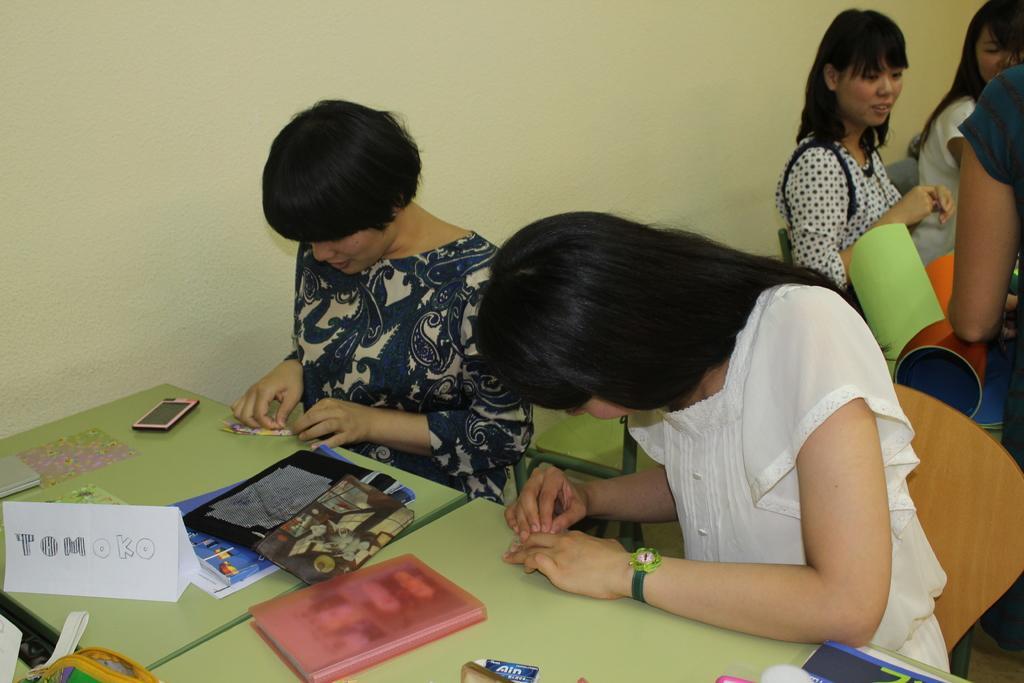In one or two sentences, can you explain what this image depicts? There are few women sitting on the chairs. These are the tables. I can see the books, name board, mobile phone and few other things on the tables. On the right side of the image, I can see a person standing. I think these are the colorful papers. This is the wall. 